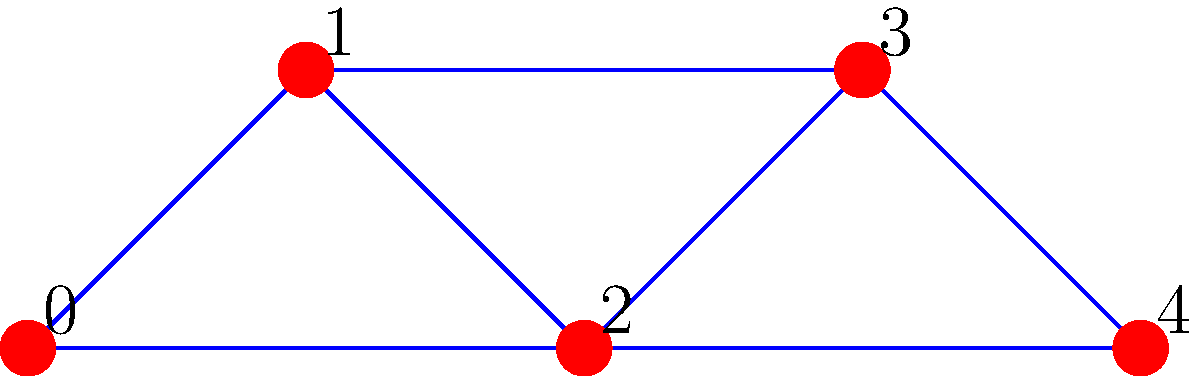Given the connected graph above with 5 vertices and 7 edges, determine the minimum spanning tree. What is the sum of the edge weights in this minimum spanning tree? To find the minimum spanning tree, we can use Kruskal's algorithm:

1) Sort the edges by weight in ascending order:
   (3,4) : 3
   (2,4) : 4
   (0,2) : 5
   (2,3) : 6
   (0,1) : 7
   (1,2) : 8
   (1,3) : 9

2) Start with an empty set of edges and add edges in order, skipping those that would create a cycle:

   a) Add (3,4) : 3
   b) Add (2,4) : 4
   c) Add (0,2) : 5
   d) Add (2,3) : 6 (Skip, would create a cycle)
   e) Add (0,1) : 7

3) We now have 4 edges, which is correct for a spanning tree of 5 vertices.

4) The minimum spanning tree consists of edges:
   (3,4), (2,4), (0,2), and (0,1)

5) Sum the weights: 3 + 4 + 5 + 7 = 19

Therefore, the sum of the edge weights in the minimum spanning tree is 19.
Answer: 19 